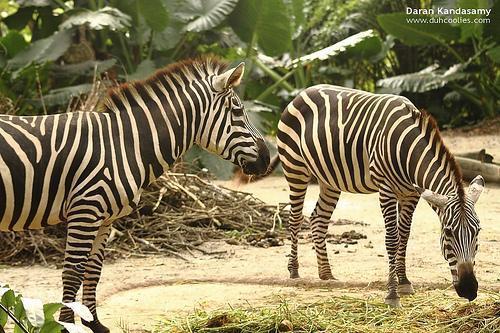How many zebra are there?
Give a very brief answer. 2. How many animals?
Give a very brief answer. 2. How many zebras can you see?
Give a very brief answer. 2. How many chairs do you see?
Give a very brief answer. 0. 